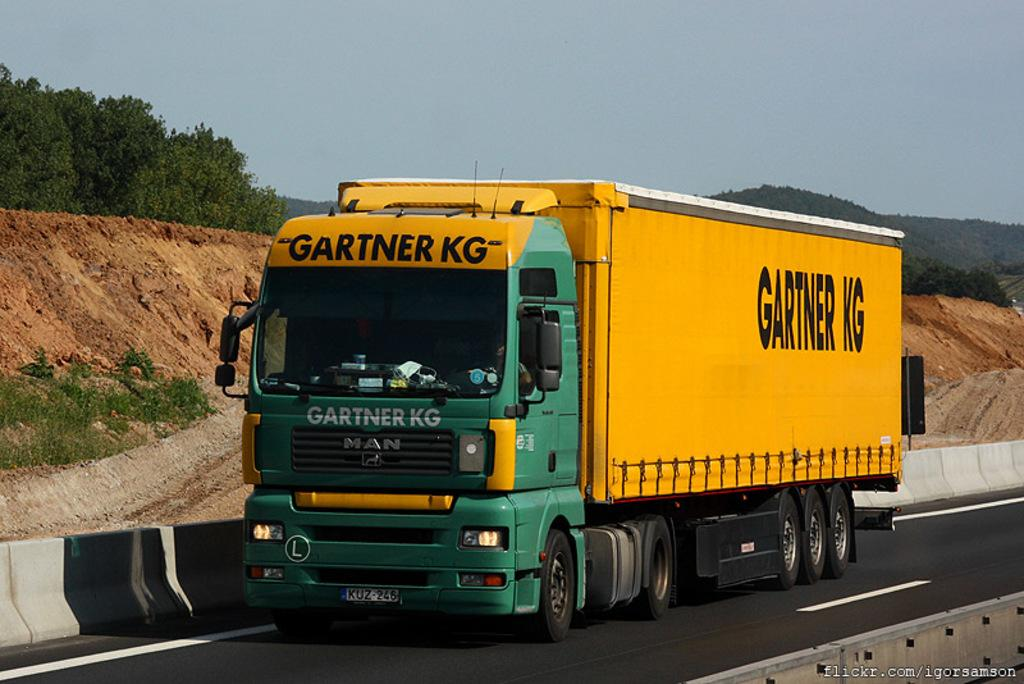What is happening in the image? There is a vehicle moving on the road in the image. What can be seen in the background of the image? There are trees, mountains, and the sky visible in the background of the image. How many prisoners can be seen escaping from the quicksand in the image? There are no prisoners or quicksand present in the image. 